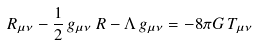Convert formula to latex. <formula><loc_0><loc_0><loc_500><loc_500>R _ { \mu \nu } - \frac { 1 } { 2 } \, g _ { \mu \nu } \, R - \Lambda \, g _ { \mu \nu } = - { 8 \pi G } \, T _ { \mu \nu }</formula> 